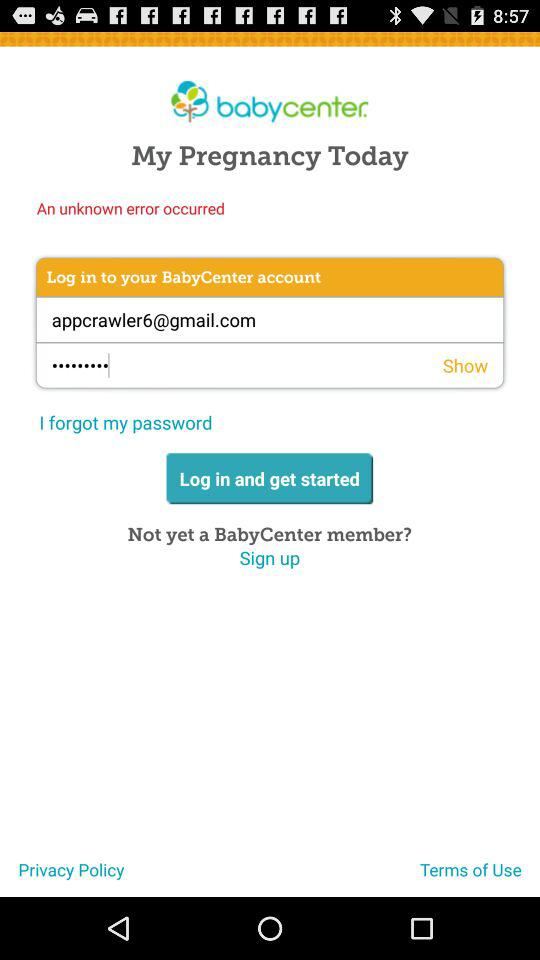What is the application name? The application name is "BabyCenter". 